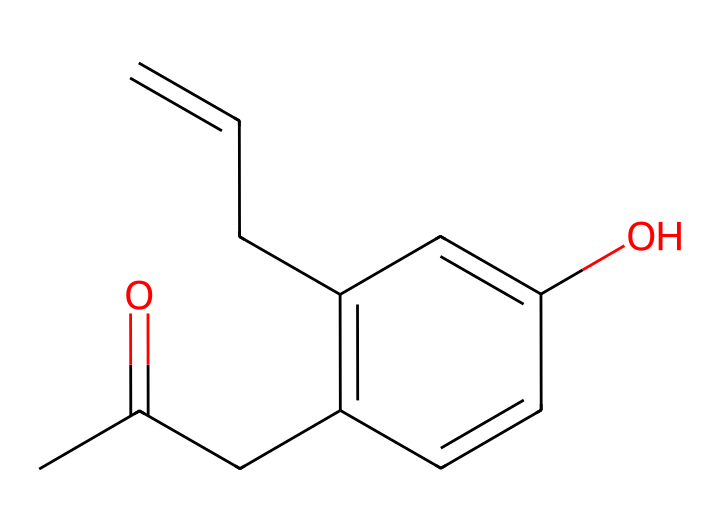What is the name of this chemical? The SMILES representation translates to the chemical name "raspberry ketone," which consists of a specific arrangement of atoms.
Answer: raspberry ketone How many carbon atoms are in this molecule? Analyzing the SMILES notation, there are a total of 10 carbon atoms present in the structure.
Answer: 10 What functional group is present in raspberry ketone? The presence of the carbonyl group (C=O) is identified in the molecule, which is characteristic of ketones.
Answer: carbonyl Does raspberry ketone contain any hydroxyl groups? The structure shows an -OH group, meaning it has one hydroxyl group that indicates it may have some phenolic properties.
Answer: yes What is the degree of unsaturation in this molecule? Counting the different elements and rings in the molecule, the degree of unsaturation is calculated to be 5, indicating the presence of multiple double bonds or rings.
Answer: 5 What is the carbon-to-hydrogen ratio in raspberry ketone? By counting the number of carbons and hydrogens from the SMILES representation, there are 10 carbons and 12 hydrogens, giving a carbon-to-hydrogen ratio of 10:12, which simplifies to 5:6.
Answer: 5:6 Is raspberry ketone considered a natural compound? Raspberry ketone is derived from natural sources, specifically from raspberries and some other fruits, confirming its classification as a natural compound.
Answer: yes 